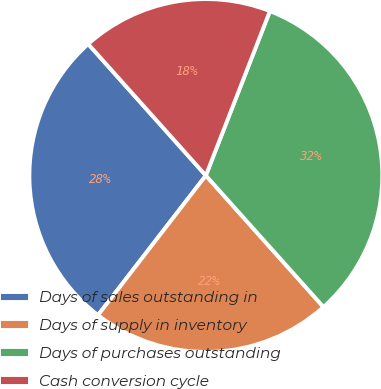<chart> <loc_0><loc_0><loc_500><loc_500><pie_chart><fcel>Days of sales outstanding in<fcel>Days of supply in inventory<fcel>Days of purchases outstanding<fcel>Cash conversion cycle<nl><fcel>27.92%<fcel>22.08%<fcel>32.47%<fcel>17.53%<nl></chart> 